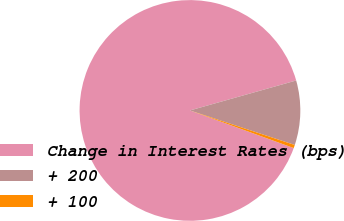<chart> <loc_0><loc_0><loc_500><loc_500><pie_chart><fcel>Change in Interest Rates (bps)<fcel>+ 200<fcel>+ 100<nl><fcel>90.09%<fcel>9.44%<fcel>0.47%<nl></chart> 